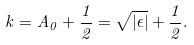<formula> <loc_0><loc_0><loc_500><loc_500>k = A _ { 0 } + \frac { 1 } { 2 } = \sqrt { | \epsilon | } + \frac { 1 } { 2 } .</formula> 